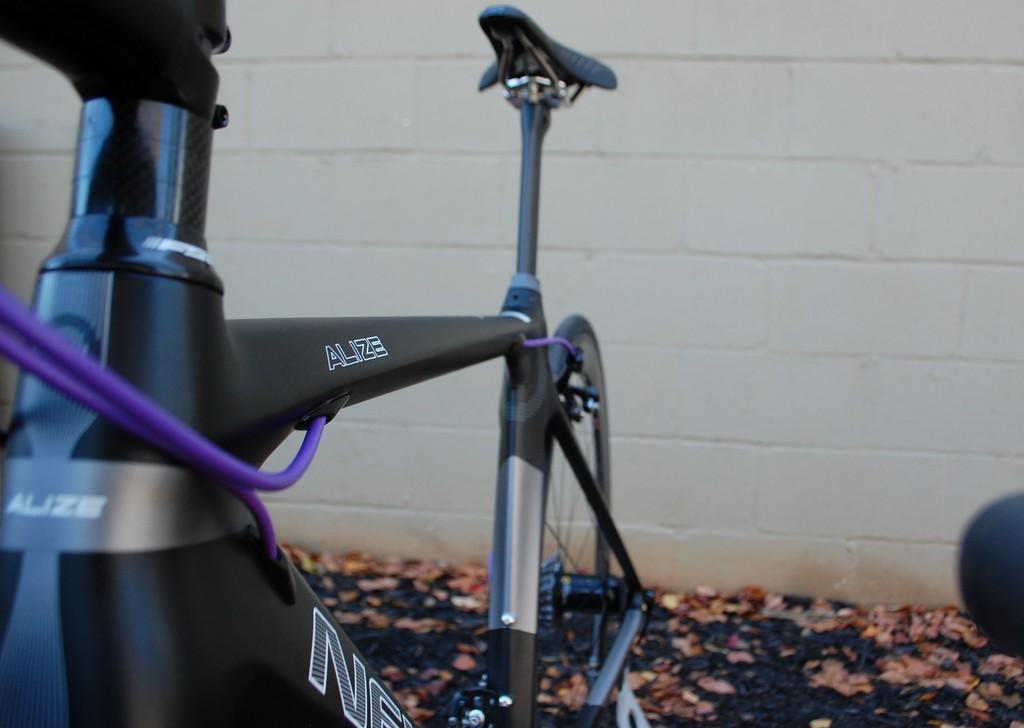Describe this image in one or two sentences. In this image we can see a bicycle parked on the ground , we can also see some dried leaves. At the top of the image we can see a wall. 